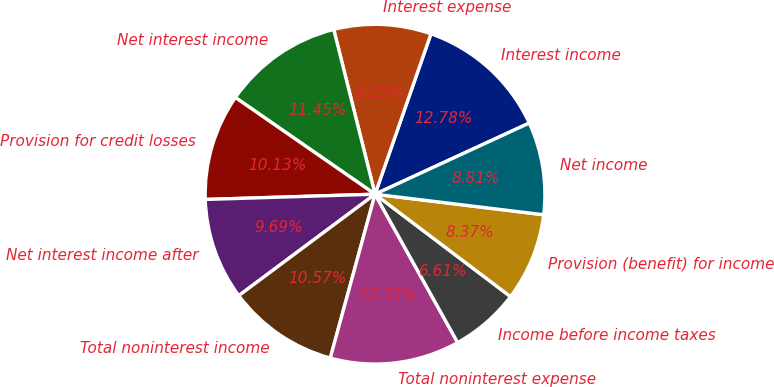<chart> <loc_0><loc_0><loc_500><loc_500><pie_chart><fcel>Interest income<fcel>Interest expense<fcel>Net interest income<fcel>Provision for credit losses<fcel>Net interest income after<fcel>Total noninterest income<fcel>Total noninterest expense<fcel>Income before income taxes<fcel>Provision (benefit) for income<fcel>Net income<nl><fcel>12.78%<fcel>9.25%<fcel>11.45%<fcel>10.13%<fcel>9.69%<fcel>10.57%<fcel>12.33%<fcel>6.61%<fcel>8.37%<fcel>8.81%<nl></chart> 